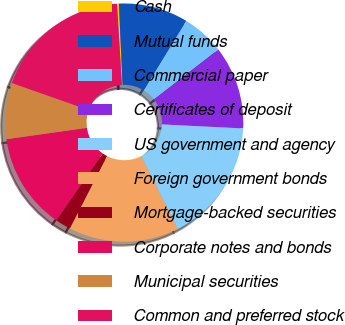Convert chart. <chart><loc_0><loc_0><loc_500><loc_500><pie_chart><fcel>Cash<fcel>Mutual funds<fcel>Commercial paper<fcel>Certificates of deposit<fcel>US government and agency<fcel>Foreign government bonds<fcel>Mortgage-backed securities<fcel>Corporate notes and bonds<fcel>Municipal securities<fcel>Common and preferred stock<nl><fcel>0.26%<fcel>9.45%<fcel>5.77%<fcel>11.29%<fcel>16.8%<fcel>14.96%<fcel>2.1%<fcel>13.12%<fcel>7.61%<fcel>18.64%<nl></chart> 